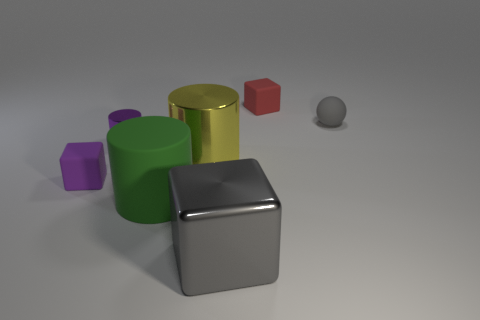Subtract all large metal blocks. How many blocks are left? 2 Add 1 green cylinders. How many objects exist? 8 Subtract all purple cylinders. How many cylinders are left? 2 Subtract all blocks. How many objects are left? 4 Add 4 yellow metal cylinders. How many yellow metal cylinders are left? 5 Add 1 yellow metal objects. How many yellow metal objects exist? 2 Subtract 1 yellow cylinders. How many objects are left? 6 Subtract all yellow blocks. Subtract all green cylinders. How many blocks are left? 3 Subtract all yellow balls. How many red cylinders are left? 0 Subtract all purple rubber cubes. Subtract all yellow metal objects. How many objects are left? 5 